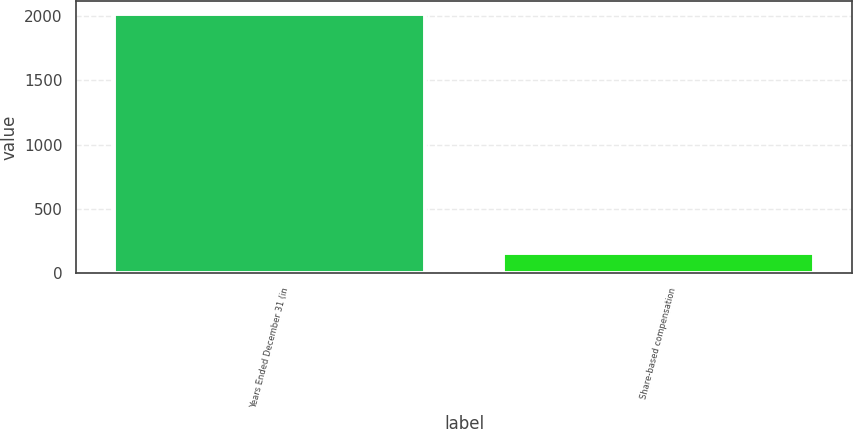Convert chart to OTSL. <chart><loc_0><loc_0><loc_500><loc_500><bar_chart><fcel>Years Ended December 31 (in<fcel>Share-based compensation<nl><fcel>2016<fcel>154<nl></chart> 